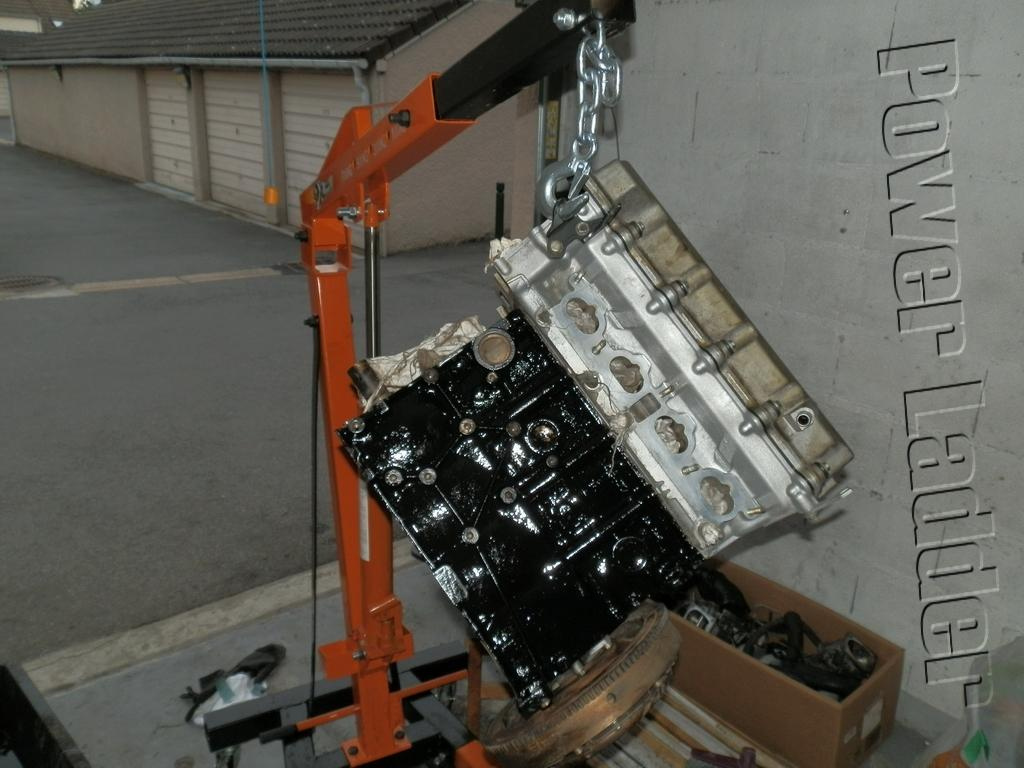What is the main object in the image? There is a machine in the image. What else can be seen in the image besides the machine? There is a box and houses in the image. How many windows are visible on the machine in the image? There are no windows visible on the machine in the image. 